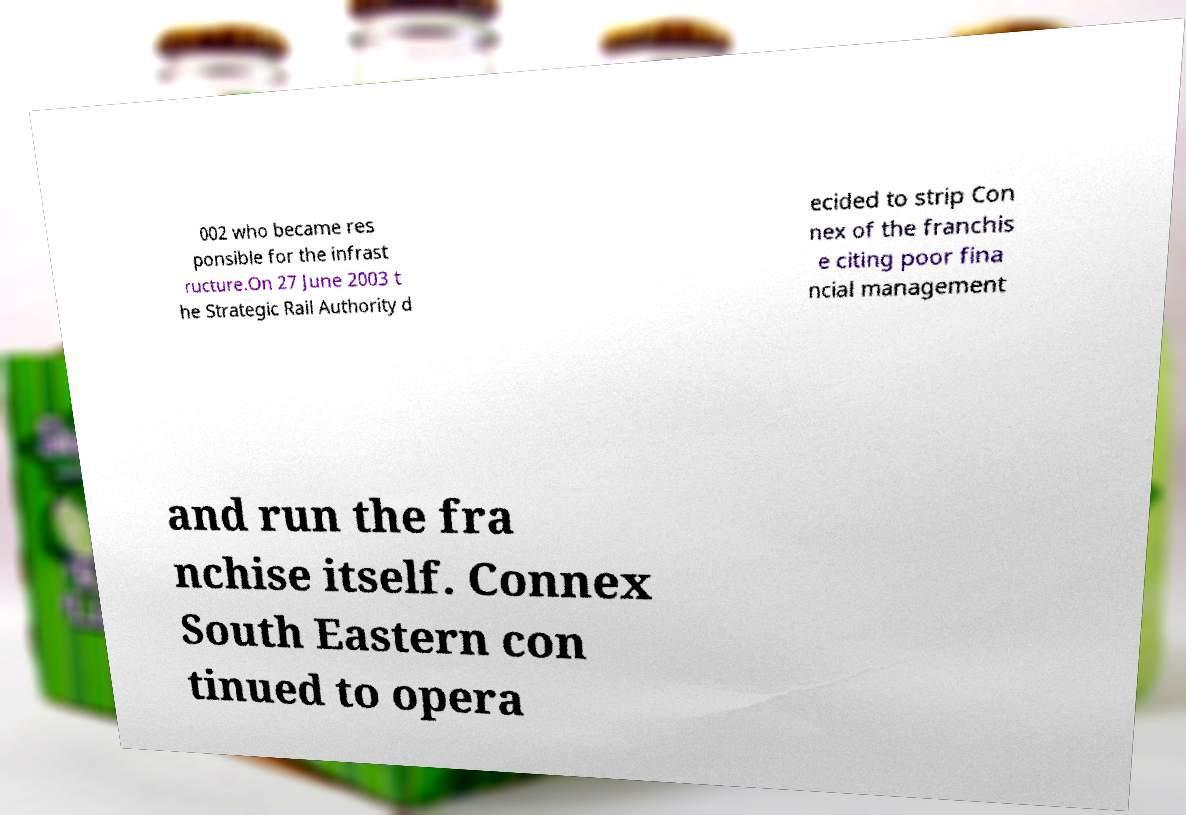Could you assist in decoding the text presented in this image and type it out clearly? 002 who became res ponsible for the infrast ructure.On 27 June 2003 t he Strategic Rail Authority d ecided to strip Con nex of the franchis e citing poor fina ncial management and run the fra nchise itself. Connex South Eastern con tinued to opera 